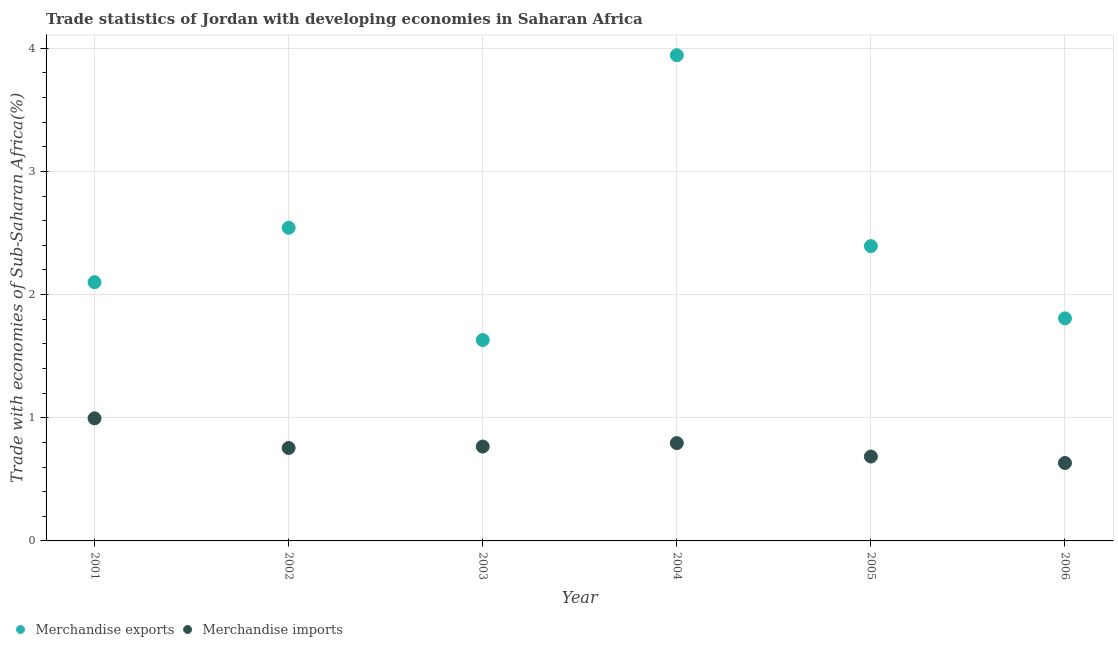How many different coloured dotlines are there?
Offer a terse response. 2. Is the number of dotlines equal to the number of legend labels?
Keep it short and to the point. Yes. What is the merchandise imports in 2006?
Your response must be concise. 0.63. Across all years, what is the maximum merchandise exports?
Provide a short and direct response. 3.94. Across all years, what is the minimum merchandise imports?
Give a very brief answer. 0.63. In which year was the merchandise exports minimum?
Your answer should be compact. 2003. What is the total merchandise exports in the graph?
Your answer should be compact. 14.42. What is the difference between the merchandise exports in 2003 and that in 2005?
Offer a terse response. -0.76. What is the difference between the merchandise imports in 2003 and the merchandise exports in 2004?
Offer a very short reply. -3.18. What is the average merchandise imports per year?
Offer a terse response. 0.77. In the year 2003, what is the difference between the merchandise imports and merchandise exports?
Provide a succinct answer. -0.86. In how many years, is the merchandise imports greater than 1.2 %?
Provide a succinct answer. 0. What is the ratio of the merchandise exports in 2001 to that in 2005?
Offer a very short reply. 0.88. What is the difference between the highest and the second highest merchandise imports?
Provide a succinct answer. 0.2. What is the difference between the highest and the lowest merchandise exports?
Your answer should be compact. 2.31. In how many years, is the merchandise exports greater than the average merchandise exports taken over all years?
Ensure brevity in your answer.  2. Is the sum of the merchandise exports in 2003 and 2005 greater than the maximum merchandise imports across all years?
Your answer should be compact. Yes. Does the merchandise exports monotonically increase over the years?
Your response must be concise. No. Is the merchandise imports strictly greater than the merchandise exports over the years?
Make the answer very short. No. How many dotlines are there?
Offer a very short reply. 2. How many years are there in the graph?
Give a very brief answer. 6. Does the graph contain any zero values?
Keep it short and to the point. No. Does the graph contain grids?
Offer a terse response. Yes. Where does the legend appear in the graph?
Make the answer very short. Bottom left. How are the legend labels stacked?
Keep it short and to the point. Horizontal. What is the title of the graph?
Provide a succinct answer. Trade statistics of Jordan with developing economies in Saharan Africa. Does "Health Care" appear as one of the legend labels in the graph?
Your answer should be compact. No. What is the label or title of the Y-axis?
Your answer should be compact. Trade with economies of Sub-Saharan Africa(%). What is the Trade with economies of Sub-Saharan Africa(%) of Merchandise exports in 2001?
Give a very brief answer. 2.1. What is the Trade with economies of Sub-Saharan Africa(%) in Merchandise imports in 2001?
Offer a terse response. 1. What is the Trade with economies of Sub-Saharan Africa(%) in Merchandise exports in 2002?
Make the answer very short. 2.54. What is the Trade with economies of Sub-Saharan Africa(%) of Merchandise imports in 2002?
Your answer should be compact. 0.75. What is the Trade with economies of Sub-Saharan Africa(%) in Merchandise exports in 2003?
Make the answer very short. 1.63. What is the Trade with economies of Sub-Saharan Africa(%) of Merchandise imports in 2003?
Offer a terse response. 0.77. What is the Trade with economies of Sub-Saharan Africa(%) of Merchandise exports in 2004?
Make the answer very short. 3.94. What is the Trade with economies of Sub-Saharan Africa(%) of Merchandise imports in 2004?
Provide a succinct answer. 0.79. What is the Trade with economies of Sub-Saharan Africa(%) of Merchandise exports in 2005?
Offer a very short reply. 2.39. What is the Trade with economies of Sub-Saharan Africa(%) of Merchandise imports in 2005?
Your response must be concise. 0.68. What is the Trade with economies of Sub-Saharan Africa(%) in Merchandise exports in 2006?
Keep it short and to the point. 1.81. What is the Trade with economies of Sub-Saharan Africa(%) of Merchandise imports in 2006?
Provide a succinct answer. 0.63. Across all years, what is the maximum Trade with economies of Sub-Saharan Africa(%) in Merchandise exports?
Give a very brief answer. 3.94. Across all years, what is the maximum Trade with economies of Sub-Saharan Africa(%) in Merchandise imports?
Your answer should be compact. 1. Across all years, what is the minimum Trade with economies of Sub-Saharan Africa(%) of Merchandise exports?
Ensure brevity in your answer.  1.63. Across all years, what is the minimum Trade with economies of Sub-Saharan Africa(%) in Merchandise imports?
Provide a succinct answer. 0.63. What is the total Trade with economies of Sub-Saharan Africa(%) of Merchandise exports in the graph?
Your answer should be compact. 14.42. What is the total Trade with economies of Sub-Saharan Africa(%) of Merchandise imports in the graph?
Ensure brevity in your answer.  4.63. What is the difference between the Trade with economies of Sub-Saharan Africa(%) of Merchandise exports in 2001 and that in 2002?
Give a very brief answer. -0.44. What is the difference between the Trade with economies of Sub-Saharan Africa(%) of Merchandise imports in 2001 and that in 2002?
Offer a very short reply. 0.24. What is the difference between the Trade with economies of Sub-Saharan Africa(%) in Merchandise exports in 2001 and that in 2003?
Your answer should be compact. 0.47. What is the difference between the Trade with economies of Sub-Saharan Africa(%) in Merchandise imports in 2001 and that in 2003?
Offer a very short reply. 0.23. What is the difference between the Trade with economies of Sub-Saharan Africa(%) in Merchandise exports in 2001 and that in 2004?
Provide a succinct answer. -1.84. What is the difference between the Trade with economies of Sub-Saharan Africa(%) of Merchandise imports in 2001 and that in 2004?
Your answer should be very brief. 0.2. What is the difference between the Trade with economies of Sub-Saharan Africa(%) in Merchandise exports in 2001 and that in 2005?
Provide a short and direct response. -0.29. What is the difference between the Trade with economies of Sub-Saharan Africa(%) in Merchandise imports in 2001 and that in 2005?
Provide a short and direct response. 0.31. What is the difference between the Trade with economies of Sub-Saharan Africa(%) in Merchandise exports in 2001 and that in 2006?
Make the answer very short. 0.29. What is the difference between the Trade with economies of Sub-Saharan Africa(%) in Merchandise imports in 2001 and that in 2006?
Make the answer very short. 0.36. What is the difference between the Trade with economies of Sub-Saharan Africa(%) in Merchandise exports in 2002 and that in 2003?
Make the answer very short. 0.91. What is the difference between the Trade with economies of Sub-Saharan Africa(%) in Merchandise imports in 2002 and that in 2003?
Your answer should be very brief. -0.01. What is the difference between the Trade with economies of Sub-Saharan Africa(%) in Merchandise exports in 2002 and that in 2004?
Provide a succinct answer. -1.4. What is the difference between the Trade with economies of Sub-Saharan Africa(%) of Merchandise imports in 2002 and that in 2004?
Provide a short and direct response. -0.04. What is the difference between the Trade with economies of Sub-Saharan Africa(%) in Merchandise exports in 2002 and that in 2005?
Keep it short and to the point. 0.15. What is the difference between the Trade with economies of Sub-Saharan Africa(%) in Merchandise imports in 2002 and that in 2005?
Your answer should be compact. 0.07. What is the difference between the Trade with economies of Sub-Saharan Africa(%) of Merchandise exports in 2002 and that in 2006?
Your response must be concise. 0.74. What is the difference between the Trade with economies of Sub-Saharan Africa(%) in Merchandise imports in 2002 and that in 2006?
Offer a terse response. 0.12. What is the difference between the Trade with economies of Sub-Saharan Africa(%) of Merchandise exports in 2003 and that in 2004?
Give a very brief answer. -2.31. What is the difference between the Trade with economies of Sub-Saharan Africa(%) of Merchandise imports in 2003 and that in 2004?
Your response must be concise. -0.03. What is the difference between the Trade with economies of Sub-Saharan Africa(%) in Merchandise exports in 2003 and that in 2005?
Your response must be concise. -0.76. What is the difference between the Trade with economies of Sub-Saharan Africa(%) in Merchandise imports in 2003 and that in 2005?
Provide a succinct answer. 0.08. What is the difference between the Trade with economies of Sub-Saharan Africa(%) in Merchandise exports in 2003 and that in 2006?
Offer a terse response. -0.18. What is the difference between the Trade with economies of Sub-Saharan Africa(%) of Merchandise imports in 2003 and that in 2006?
Your answer should be very brief. 0.13. What is the difference between the Trade with economies of Sub-Saharan Africa(%) of Merchandise exports in 2004 and that in 2005?
Keep it short and to the point. 1.55. What is the difference between the Trade with economies of Sub-Saharan Africa(%) of Merchandise imports in 2004 and that in 2005?
Offer a very short reply. 0.11. What is the difference between the Trade with economies of Sub-Saharan Africa(%) in Merchandise exports in 2004 and that in 2006?
Provide a short and direct response. 2.14. What is the difference between the Trade with economies of Sub-Saharan Africa(%) in Merchandise imports in 2004 and that in 2006?
Keep it short and to the point. 0.16. What is the difference between the Trade with economies of Sub-Saharan Africa(%) of Merchandise exports in 2005 and that in 2006?
Your answer should be very brief. 0.59. What is the difference between the Trade with economies of Sub-Saharan Africa(%) of Merchandise imports in 2005 and that in 2006?
Make the answer very short. 0.05. What is the difference between the Trade with economies of Sub-Saharan Africa(%) in Merchandise exports in 2001 and the Trade with economies of Sub-Saharan Africa(%) in Merchandise imports in 2002?
Your response must be concise. 1.35. What is the difference between the Trade with economies of Sub-Saharan Africa(%) of Merchandise exports in 2001 and the Trade with economies of Sub-Saharan Africa(%) of Merchandise imports in 2003?
Your answer should be compact. 1.33. What is the difference between the Trade with economies of Sub-Saharan Africa(%) of Merchandise exports in 2001 and the Trade with economies of Sub-Saharan Africa(%) of Merchandise imports in 2004?
Provide a succinct answer. 1.31. What is the difference between the Trade with economies of Sub-Saharan Africa(%) of Merchandise exports in 2001 and the Trade with economies of Sub-Saharan Africa(%) of Merchandise imports in 2005?
Make the answer very short. 1.42. What is the difference between the Trade with economies of Sub-Saharan Africa(%) in Merchandise exports in 2001 and the Trade with economies of Sub-Saharan Africa(%) in Merchandise imports in 2006?
Ensure brevity in your answer.  1.47. What is the difference between the Trade with economies of Sub-Saharan Africa(%) of Merchandise exports in 2002 and the Trade with economies of Sub-Saharan Africa(%) of Merchandise imports in 2003?
Offer a terse response. 1.78. What is the difference between the Trade with economies of Sub-Saharan Africa(%) in Merchandise exports in 2002 and the Trade with economies of Sub-Saharan Africa(%) in Merchandise imports in 2004?
Make the answer very short. 1.75. What is the difference between the Trade with economies of Sub-Saharan Africa(%) of Merchandise exports in 2002 and the Trade with economies of Sub-Saharan Africa(%) of Merchandise imports in 2005?
Make the answer very short. 1.86. What is the difference between the Trade with economies of Sub-Saharan Africa(%) in Merchandise exports in 2002 and the Trade with economies of Sub-Saharan Africa(%) in Merchandise imports in 2006?
Give a very brief answer. 1.91. What is the difference between the Trade with economies of Sub-Saharan Africa(%) in Merchandise exports in 2003 and the Trade with economies of Sub-Saharan Africa(%) in Merchandise imports in 2004?
Your response must be concise. 0.84. What is the difference between the Trade with economies of Sub-Saharan Africa(%) in Merchandise exports in 2003 and the Trade with economies of Sub-Saharan Africa(%) in Merchandise imports in 2005?
Your response must be concise. 0.95. What is the difference between the Trade with economies of Sub-Saharan Africa(%) in Merchandise exports in 2004 and the Trade with economies of Sub-Saharan Africa(%) in Merchandise imports in 2005?
Provide a succinct answer. 3.26. What is the difference between the Trade with economies of Sub-Saharan Africa(%) in Merchandise exports in 2004 and the Trade with economies of Sub-Saharan Africa(%) in Merchandise imports in 2006?
Ensure brevity in your answer.  3.31. What is the difference between the Trade with economies of Sub-Saharan Africa(%) of Merchandise exports in 2005 and the Trade with economies of Sub-Saharan Africa(%) of Merchandise imports in 2006?
Give a very brief answer. 1.76. What is the average Trade with economies of Sub-Saharan Africa(%) in Merchandise exports per year?
Ensure brevity in your answer.  2.4. What is the average Trade with economies of Sub-Saharan Africa(%) in Merchandise imports per year?
Provide a succinct answer. 0.77. In the year 2001, what is the difference between the Trade with economies of Sub-Saharan Africa(%) in Merchandise exports and Trade with economies of Sub-Saharan Africa(%) in Merchandise imports?
Offer a very short reply. 1.1. In the year 2002, what is the difference between the Trade with economies of Sub-Saharan Africa(%) of Merchandise exports and Trade with economies of Sub-Saharan Africa(%) of Merchandise imports?
Provide a short and direct response. 1.79. In the year 2003, what is the difference between the Trade with economies of Sub-Saharan Africa(%) in Merchandise exports and Trade with economies of Sub-Saharan Africa(%) in Merchandise imports?
Your response must be concise. 0.86. In the year 2004, what is the difference between the Trade with economies of Sub-Saharan Africa(%) in Merchandise exports and Trade with economies of Sub-Saharan Africa(%) in Merchandise imports?
Offer a terse response. 3.15. In the year 2005, what is the difference between the Trade with economies of Sub-Saharan Africa(%) in Merchandise exports and Trade with economies of Sub-Saharan Africa(%) in Merchandise imports?
Ensure brevity in your answer.  1.71. In the year 2006, what is the difference between the Trade with economies of Sub-Saharan Africa(%) in Merchandise exports and Trade with economies of Sub-Saharan Africa(%) in Merchandise imports?
Your answer should be very brief. 1.17. What is the ratio of the Trade with economies of Sub-Saharan Africa(%) of Merchandise exports in 2001 to that in 2002?
Make the answer very short. 0.83. What is the ratio of the Trade with economies of Sub-Saharan Africa(%) of Merchandise imports in 2001 to that in 2002?
Your response must be concise. 1.32. What is the ratio of the Trade with economies of Sub-Saharan Africa(%) in Merchandise exports in 2001 to that in 2003?
Your answer should be very brief. 1.29. What is the ratio of the Trade with economies of Sub-Saharan Africa(%) of Merchandise imports in 2001 to that in 2003?
Your response must be concise. 1.3. What is the ratio of the Trade with economies of Sub-Saharan Africa(%) in Merchandise exports in 2001 to that in 2004?
Your response must be concise. 0.53. What is the ratio of the Trade with economies of Sub-Saharan Africa(%) in Merchandise imports in 2001 to that in 2004?
Ensure brevity in your answer.  1.25. What is the ratio of the Trade with economies of Sub-Saharan Africa(%) of Merchandise exports in 2001 to that in 2005?
Offer a terse response. 0.88. What is the ratio of the Trade with economies of Sub-Saharan Africa(%) in Merchandise imports in 2001 to that in 2005?
Offer a terse response. 1.45. What is the ratio of the Trade with economies of Sub-Saharan Africa(%) in Merchandise exports in 2001 to that in 2006?
Ensure brevity in your answer.  1.16. What is the ratio of the Trade with economies of Sub-Saharan Africa(%) in Merchandise imports in 2001 to that in 2006?
Your response must be concise. 1.57. What is the ratio of the Trade with economies of Sub-Saharan Africa(%) of Merchandise exports in 2002 to that in 2003?
Your answer should be compact. 1.56. What is the ratio of the Trade with economies of Sub-Saharan Africa(%) of Merchandise imports in 2002 to that in 2003?
Make the answer very short. 0.98. What is the ratio of the Trade with economies of Sub-Saharan Africa(%) of Merchandise exports in 2002 to that in 2004?
Your response must be concise. 0.64. What is the ratio of the Trade with economies of Sub-Saharan Africa(%) of Merchandise imports in 2002 to that in 2004?
Make the answer very short. 0.95. What is the ratio of the Trade with economies of Sub-Saharan Africa(%) in Merchandise exports in 2002 to that in 2005?
Your answer should be very brief. 1.06. What is the ratio of the Trade with economies of Sub-Saharan Africa(%) of Merchandise imports in 2002 to that in 2005?
Your answer should be compact. 1.1. What is the ratio of the Trade with economies of Sub-Saharan Africa(%) in Merchandise exports in 2002 to that in 2006?
Your answer should be compact. 1.41. What is the ratio of the Trade with economies of Sub-Saharan Africa(%) in Merchandise imports in 2002 to that in 2006?
Your answer should be compact. 1.19. What is the ratio of the Trade with economies of Sub-Saharan Africa(%) of Merchandise exports in 2003 to that in 2004?
Give a very brief answer. 0.41. What is the ratio of the Trade with economies of Sub-Saharan Africa(%) of Merchandise imports in 2003 to that in 2004?
Your response must be concise. 0.96. What is the ratio of the Trade with economies of Sub-Saharan Africa(%) in Merchandise exports in 2003 to that in 2005?
Keep it short and to the point. 0.68. What is the ratio of the Trade with economies of Sub-Saharan Africa(%) in Merchandise imports in 2003 to that in 2005?
Offer a very short reply. 1.12. What is the ratio of the Trade with economies of Sub-Saharan Africa(%) in Merchandise exports in 2003 to that in 2006?
Offer a very short reply. 0.9. What is the ratio of the Trade with economies of Sub-Saharan Africa(%) in Merchandise imports in 2003 to that in 2006?
Provide a succinct answer. 1.21. What is the ratio of the Trade with economies of Sub-Saharan Africa(%) of Merchandise exports in 2004 to that in 2005?
Provide a short and direct response. 1.65. What is the ratio of the Trade with economies of Sub-Saharan Africa(%) of Merchandise imports in 2004 to that in 2005?
Provide a succinct answer. 1.16. What is the ratio of the Trade with economies of Sub-Saharan Africa(%) in Merchandise exports in 2004 to that in 2006?
Offer a terse response. 2.18. What is the ratio of the Trade with economies of Sub-Saharan Africa(%) of Merchandise imports in 2004 to that in 2006?
Provide a short and direct response. 1.26. What is the ratio of the Trade with economies of Sub-Saharan Africa(%) of Merchandise exports in 2005 to that in 2006?
Ensure brevity in your answer.  1.32. What is the ratio of the Trade with economies of Sub-Saharan Africa(%) in Merchandise imports in 2005 to that in 2006?
Provide a short and direct response. 1.08. What is the difference between the highest and the second highest Trade with economies of Sub-Saharan Africa(%) in Merchandise exports?
Ensure brevity in your answer.  1.4. What is the difference between the highest and the second highest Trade with economies of Sub-Saharan Africa(%) in Merchandise imports?
Offer a terse response. 0.2. What is the difference between the highest and the lowest Trade with economies of Sub-Saharan Africa(%) in Merchandise exports?
Ensure brevity in your answer.  2.31. What is the difference between the highest and the lowest Trade with economies of Sub-Saharan Africa(%) of Merchandise imports?
Provide a succinct answer. 0.36. 